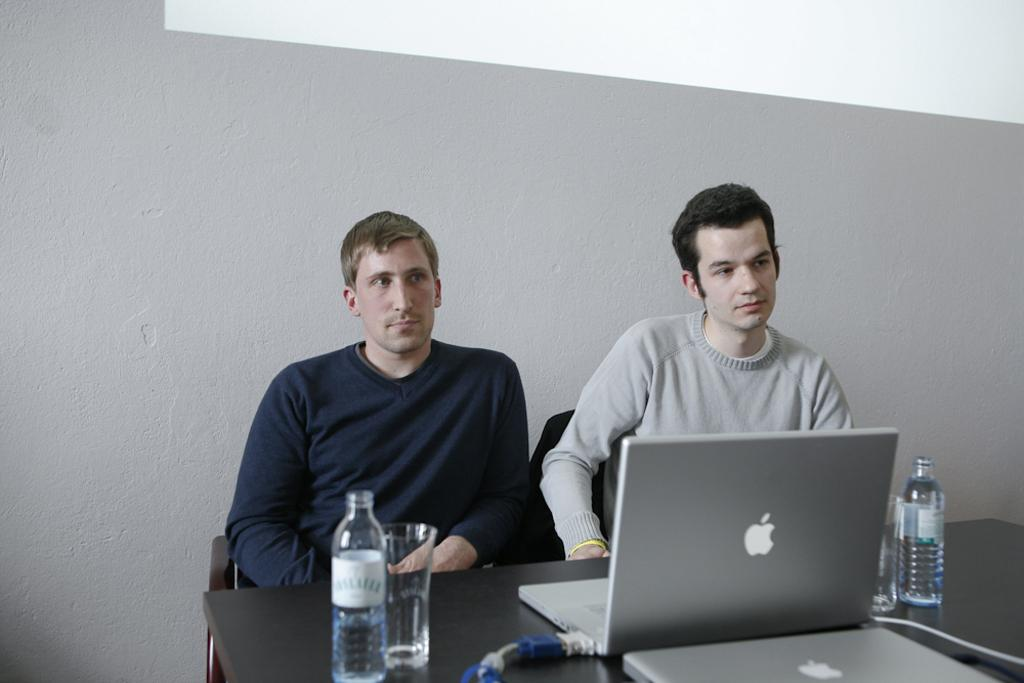How many people are sitting in the image? There are two persons sitting on chairs in the image. What are the chairs near in the image? The chairs are near a table in the image. What electronic devices can be seen on the table? There are laptops on the table in the image. What else can be seen on the table besides laptops? There are bottles and glasses on the table in the image. What type of suit is the person on the left wearing in the image? There is no suit visible in the image; the persons are not wearing any clothing mentioned in the facts. 